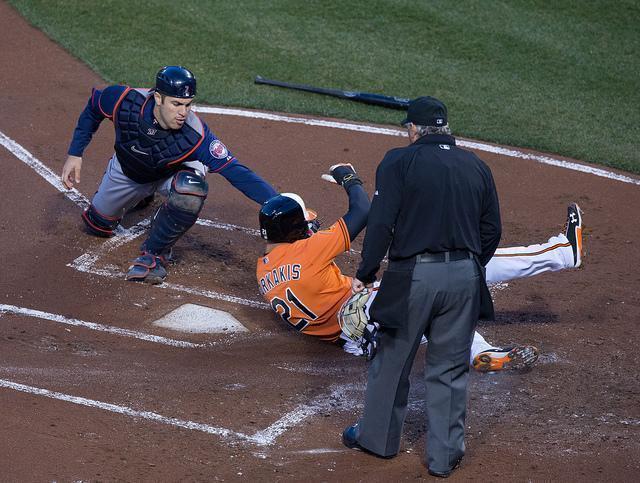What is the position of the man who is standing?
Answer the question by selecting the correct answer among the 4 following choices.
Options: Umpire, pitcher, catcher, coach. Umpire. 